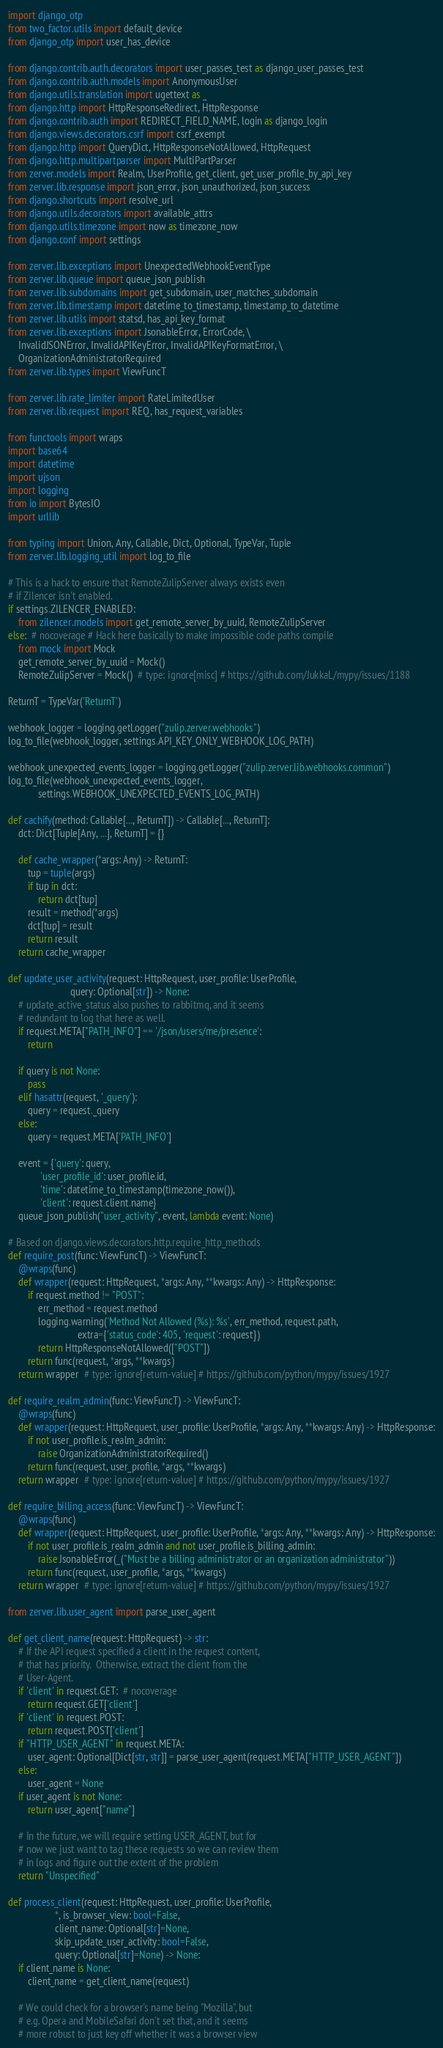Convert code to text. <code><loc_0><loc_0><loc_500><loc_500><_Python_>import django_otp
from two_factor.utils import default_device
from django_otp import user_has_device

from django.contrib.auth.decorators import user_passes_test as django_user_passes_test
from django.contrib.auth.models import AnonymousUser
from django.utils.translation import ugettext as _
from django.http import HttpResponseRedirect, HttpResponse
from django.contrib.auth import REDIRECT_FIELD_NAME, login as django_login
from django.views.decorators.csrf import csrf_exempt
from django.http import QueryDict, HttpResponseNotAllowed, HttpRequest
from django.http.multipartparser import MultiPartParser
from zerver.models import Realm, UserProfile, get_client, get_user_profile_by_api_key
from zerver.lib.response import json_error, json_unauthorized, json_success
from django.shortcuts import resolve_url
from django.utils.decorators import available_attrs
from django.utils.timezone import now as timezone_now
from django.conf import settings

from zerver.lib.exceptions import UnexpectedWebhookEventType
from zerver.lib.queue import queue_json_publish
from zerver.lib.subdomains import get_subdomain, user_matches_subdomain
from zerver.lib.timestamp import datetime_to_timestamp, timestamp_to_datetime
from zerver.lib.utils import statsd, has_api_key_format
from zerver.lib.exceptions import JsonableError, ErrorCode, \
    InvalidJSONError, InvalidAPIKeyError, InvalidAPIKeyFormatError, \
    OrganizationAdministratorRequired
from zerver.lib.types import ViewFuncT

from zerver.lib.rate_limiter import RateLimitedUser
from zerver.lib.request import REQ, has_request_variables

from functools import wraps
import base64
import datetime
import ujson
import logging
from io import BytesIO
import urllib

from typing import Union, Any, Callable, Dict, Optional, TypeVar, Tuple
from zerver.lib.logging_util import log_to_file

# This is a hack to ensure that RemoteZulipServer always exists even
# if Zilencer isn't enabled.
if settings.ZILENCER_ENABLED:
    from zilencer.models import get_remote_server_by_uuid, RemoteZulipServer
else:  # nocoverage # Hack here basically to make impossible code paths compile
    from mock import Mock
    get_remote_server_by_uuid = Mock()
    RemoteZulipServer = Mock()  # type: ignore[misc] # https://github.com/JukkaL/mypy/issues/1188

ReturnT = TypeVar('ReturnT')

webhook_logger = logging.getLogger("zulip.zerver.webhooks")
log_to_file(webhook_logger, settings.API_KEY_ONLY_WEBHOOK_LOG_PATH)

webhook_unexpected_events_logger = logging.getLogger("zulip.zerver.lib.webhooks.common")
log_to_file(webhook_unexpected_events_logger,
            settings.WEBHOOK_UNEXPECTED_EVENTS_LOG_PATH)

def cachify(method: Callable[..., ReturnT]) -> Callable[..., ReturnT]:
    dct: Dict[Tuple[Any, ...], ReturnT] = {}

    def cache_wrapper(*args: Any) -> ReturnT:
        tup = tuple(args)
        if tup in dct:
            return dct[tup]
        result = method(*args)
        dct[tup] = result
        return result
    return cache_wrapper

def update_user_activity(request: HttpRequest, user_profile: UserProfile,
                         query: Optional[str]) -> None:
    # update_active_status also pushes to rabbitmq, and it seems
    # redundant to log that here as well.
    if request.META["PATH_INFO"] == '/json/users/me/presence':
        return

    if query is not None:
        pass
    elif hasattr(request, '_query'):
        query = request._query
    else:
        query = request.META['PATH_INFO']

    event = {'query': query,
             'user_profile_id': user_profile.id,
             'time': datetime_to_timestamp(timezone_now()),
             'client': request.client.name}
    queue_json_publish("user_activity", event, lambda event: None)

# Based on django.views.decorators.http.require_http_methods
def require_post(func: ViewFuncT) -> ViewFuncT:
    @wraps(func)
    def wrapper(request: HttpRequest, *args: Any, **kwargs: Any) -> HttpResponse:
        if request.method != "POST":
            err_method = request.method
            logging.warning('Method Not Allowed (%s): %s', err_method, request.path,
                            extra={'status_code': 405, 'request': request})
            return HttpResponseNotAllowed(["POST"])
        return func(request, *args, **kwargs)
    return wrapper  # type: ignore[return-value] # https://github.com/python/mypy/issues/1927

def require_realm_admin(func: ViewFuncT) -> ViewFuncT:
    @wraps(func)
    def wrapper(request: HttpRequest, user_profile: UserProfile, *args: Any, **kwargs: Any) -> HttpResponse:
        if not user_profile.is_realm_admin:
            raise OrganizationAdministratorRequired()
        return func(request, user_profile, *args, **kwargs)
    return wrapper  # type: ignore[return-value] # https://github.com/python/mypy/issues/1927

def require_billing_access(func: ViewFuncT) -> ViewFuncT:
    @wraps(func)
    def wrapper(request: HttpRequest, user_profile: UserProfile, *args: Any, **kwargs: Any) -> HttpResponse:
        if not user_profile.is_realm_admin and not user_profile.is_billing_admin:
            raise JsonableError(_("Must be a billing administrator or an organization administrator"))
        return func(request, user_profile, *args, **kwargs)
    return wrapper  # type: ignore[return-value] # https://github.com/python/mypy/issues/1927

from zerver.lib.user_agent import parse_user_agent

def get_client_name(request: HttpRequest) -> str:
    # If the API request specified a client in the request content,
    # that has priority.  Otherwise, extract the client from the
    # User-Agent.
    if 'client' in request.GET:  # nocoverage
        return request.GET['client']
    if 'client' in request.POST:
        return request.POST['client']
    if "HTTP_USER_AGENT" in request.META:
        user_agent: Optional[Dict[str, str]] = parse_user_agent(request.META["HTTP_USER_AGENT"])
    else:
        user_agent = None
    if user_agent is not None:
        return user_agent["name"]

    # In the future, we will require setting USER_AGENT, but for
    # now we just want to tag these requests so we can review them
    # in logs and figure out the extent of the problem
    return "Unspecified"

def process_client(request: HttpRequest, user_profile: UserProfile,
                   *, is_browser_view: bool=False,
                   client_name: Optional[str]=None,
                   skip_update_user_activity: bool=False,
                   query: Optional[str]=None) -> None:
    if client_name is None:
        client_name = get_client_name(request)

    # We could check for a browser's name being "Mozilla", but
    # e.g. Opera and MobileSafari don't set that, and it seems
    # more robust to just key off whether it was a browser view</code> 